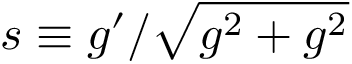Convert formula to latex. <formula><loc_0><loc_0><loc_500><loc_500>s \equiv g ^ { \prime } / \sqrt { g ^ { 2 } + g ^ { 2 } }</formula> 